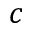Convert formula to latex. <formula><loc_0><loc_0><loc_500><loc_500>c</formula> 